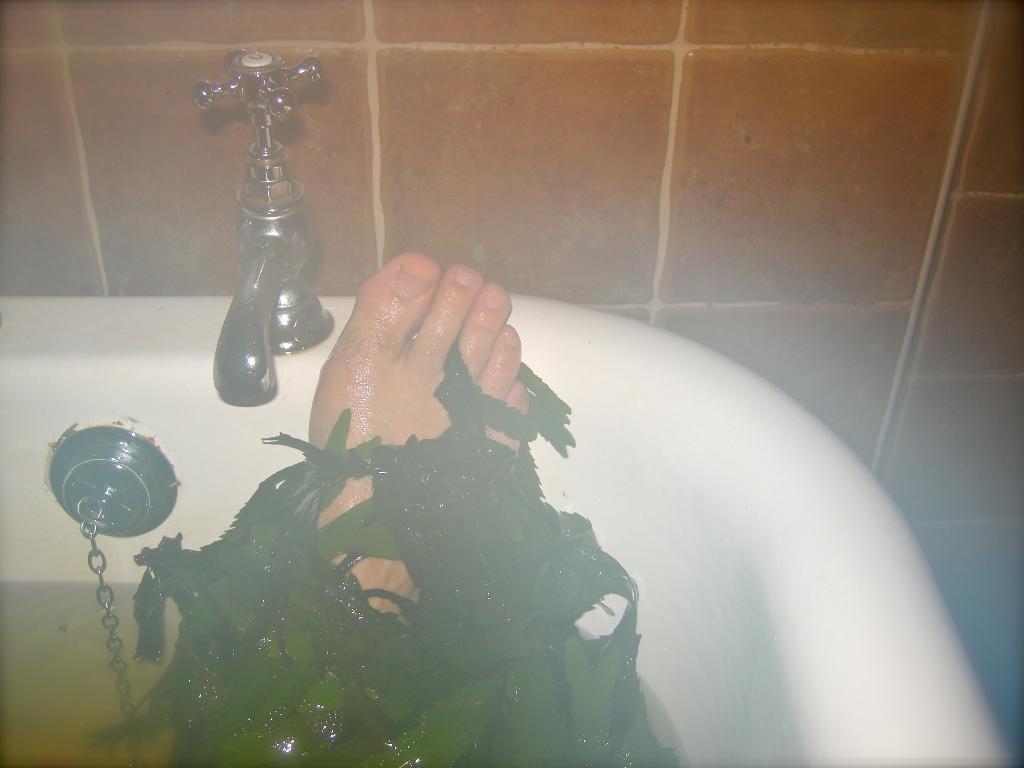How would you summarize this image in a sentence or two? In this image I can see the tap and the sink. I can see the person's leg in the sink. I can see the green color leaves on the leg. To the side I can see the chain and the water. 